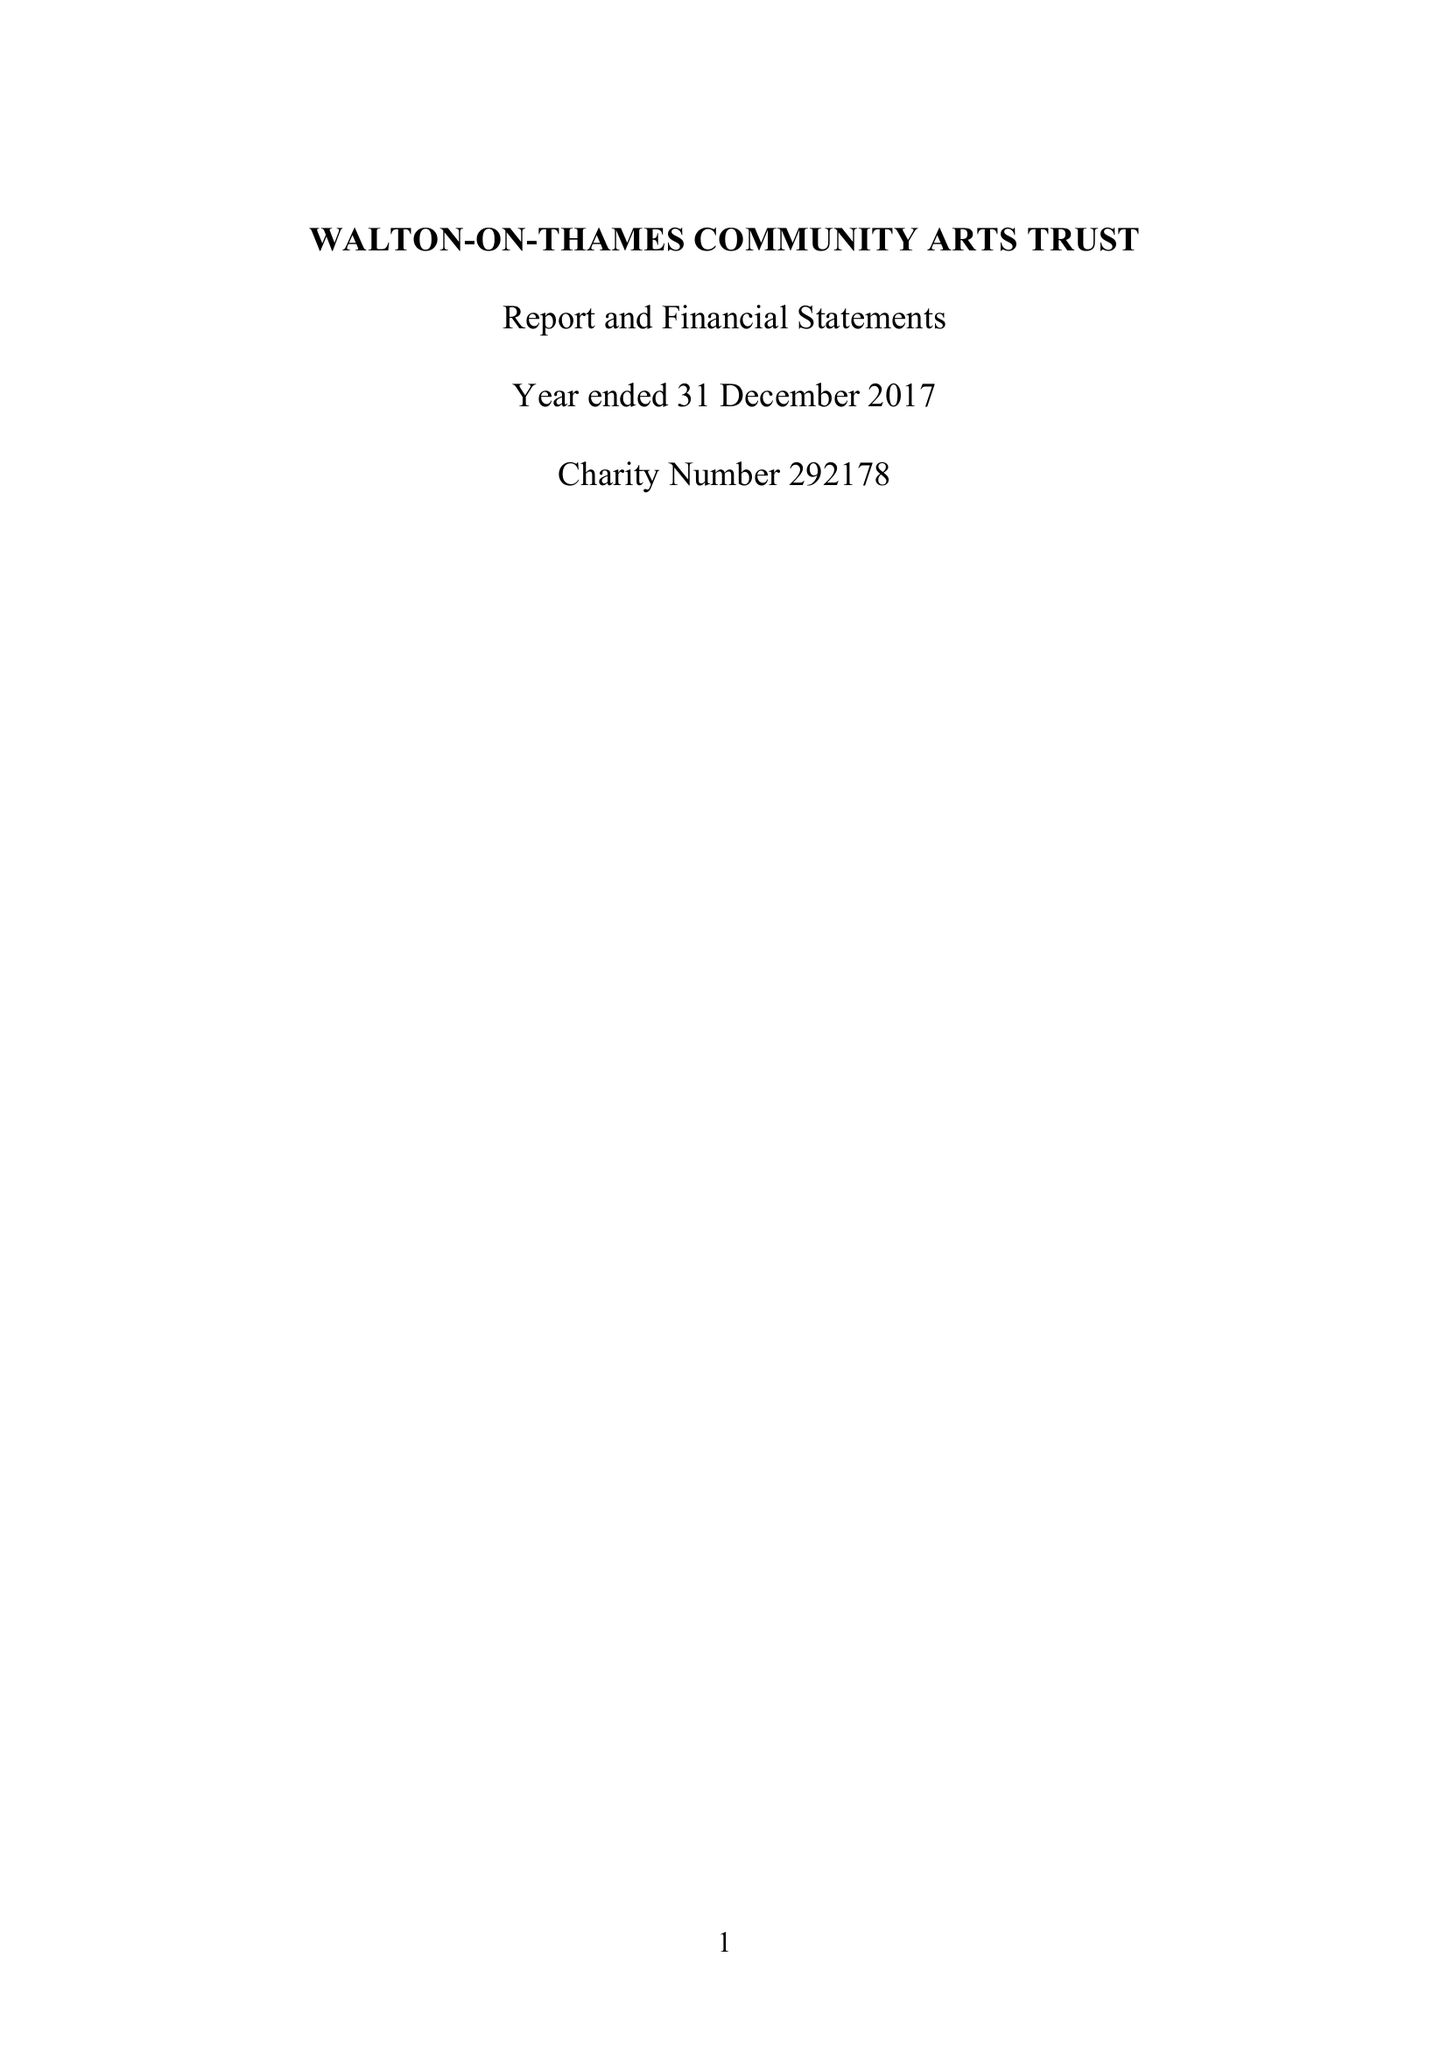What is the value for the address__post_town?
Answer the question using a single word or phrase. WALTON-ON-THAMES 